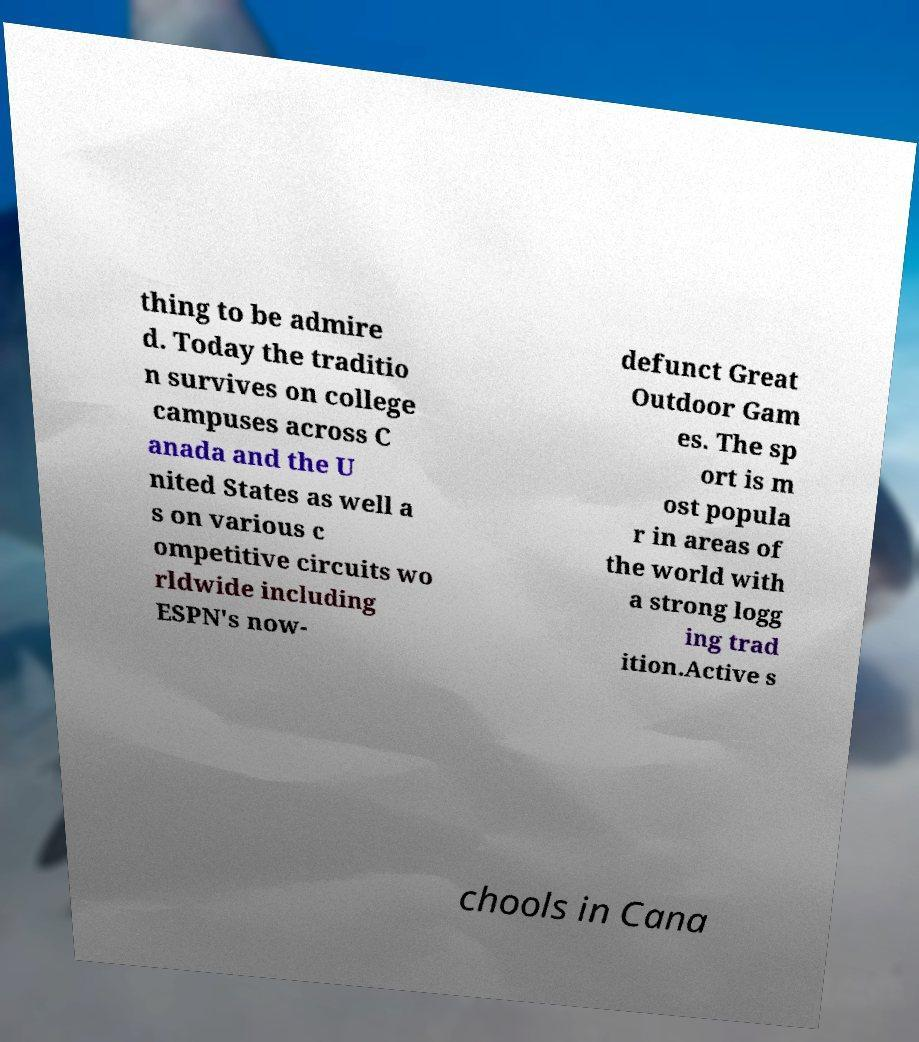Can you accurately transcribe the text from the provided image for me? thing to be admire d. Today the traditio n survives on college campuses across C anada and the U nited States as well a s on various c ompetitive circuits wo rldwide including ESPN's now- defunct Great Outdoor Gam es. The sp ort is m ost popula r in areas of the world with a strong logg ing trad ition.Active s chools in Cana 